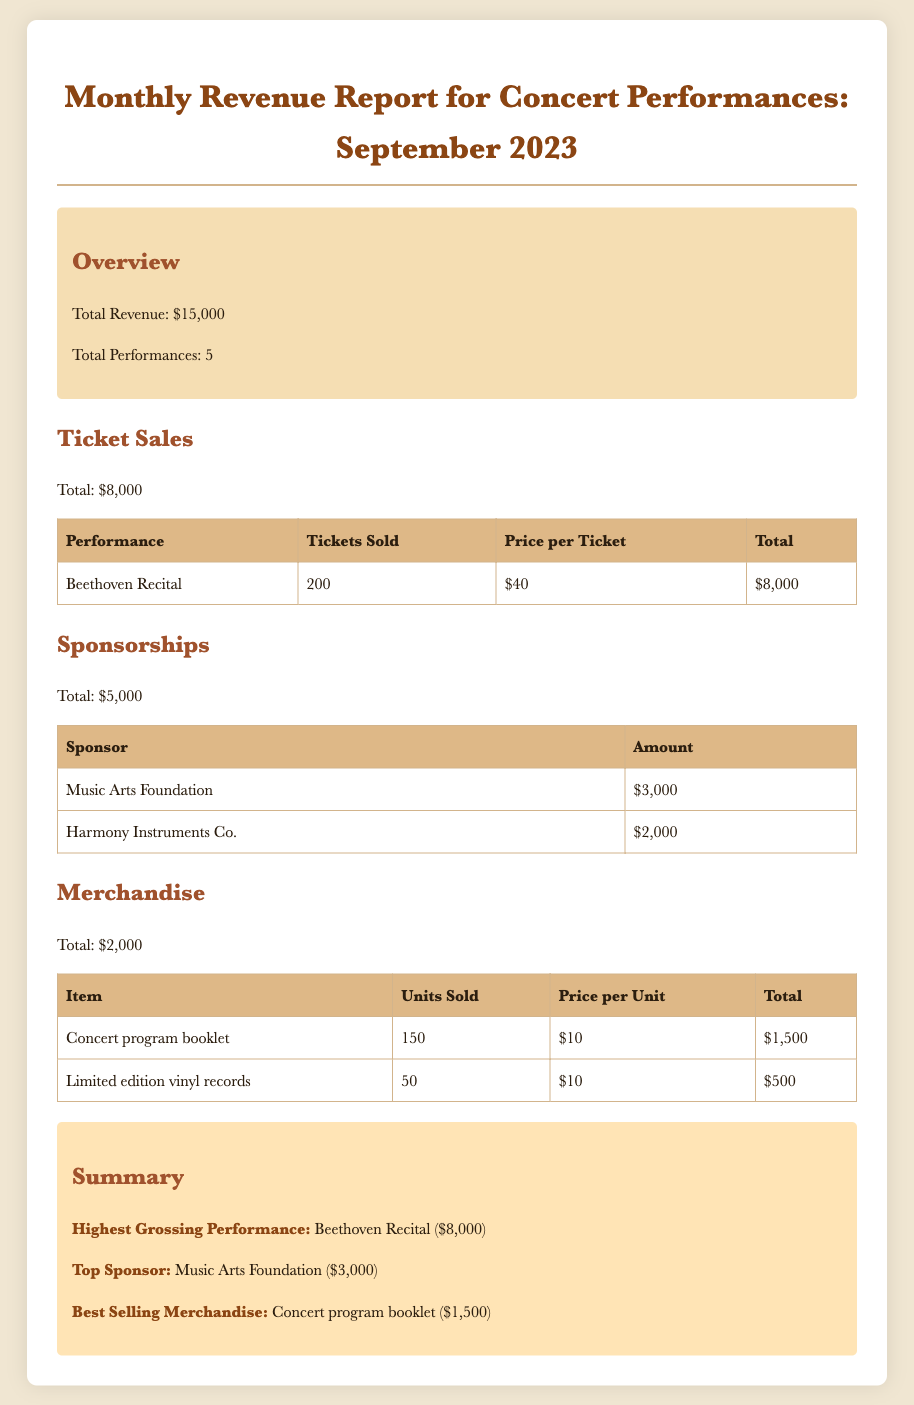What is the total revenue? The total revenue is provided in the overview section of the document, which states that it is $15,000.
Answer: $15,000 How many performances were there? The document indicates in the overview section that there were a total of 5 performances.
Answer: 5 What was the total ticket sales? The ticket sales total is specified beneath the Ticket Sales section, which states it is $8,000.
Answer: $8,000 Who was the top sponsor? The summary section highlights that the top sponsor is the Music Arts Foundation.
Answer: Music Arts Foundation What was the highest grossing performance? The summary section states that the highest grossing performance is the Beethoven Recital, which earned $8,000.
Answer: Beethoven Recital How many concert program booklets were sold? The Merchandise section lists that 150 concert program booklets were sold.
Answer: 150 What was the total merchandise revenue? The total revenue from merchandise is provided in the Merchandise section, amounting to $2,000.
Answer: $2,000 What was the price per ticket for the Beethoven Recital? The details in the Ticket Sales table state that the price per ticket for the Beethoven Recital was $40.
Answer: $40 What was the amount contributed by Harmony Instruments Co.? The Sponsorships table specifies that Harmony Instruments Co. contributed $2,000.
Answer: $2,000 